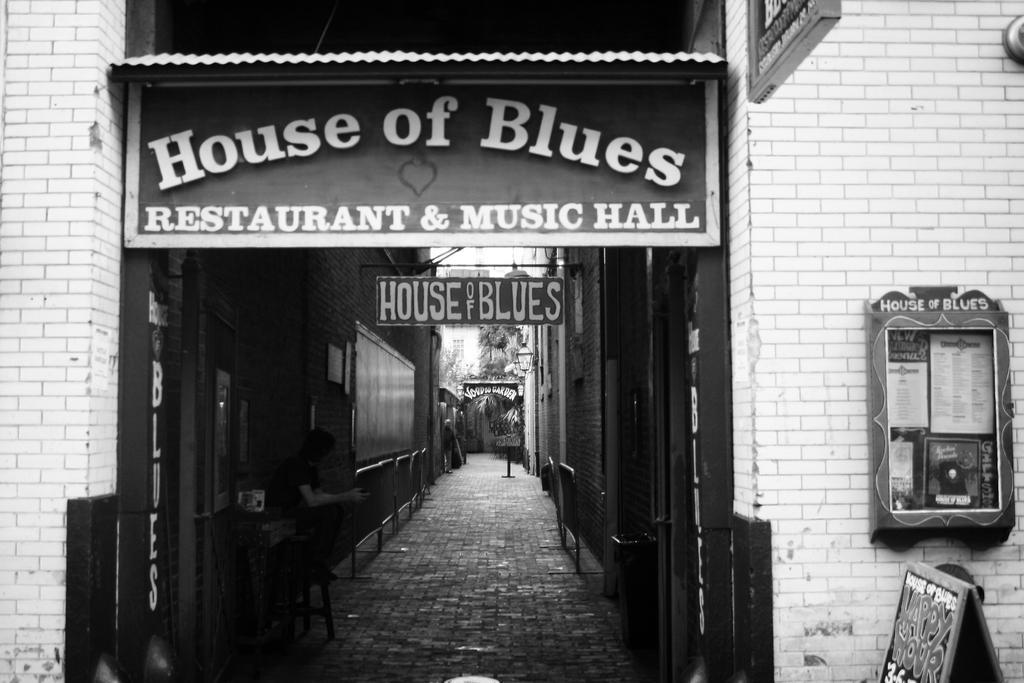Can you describe this image briefly? In the foreground of this black and white image, there is a building. In the middle, there is a path and we can also see few boats and the wall and also a man sitting on the stool side to the path. 